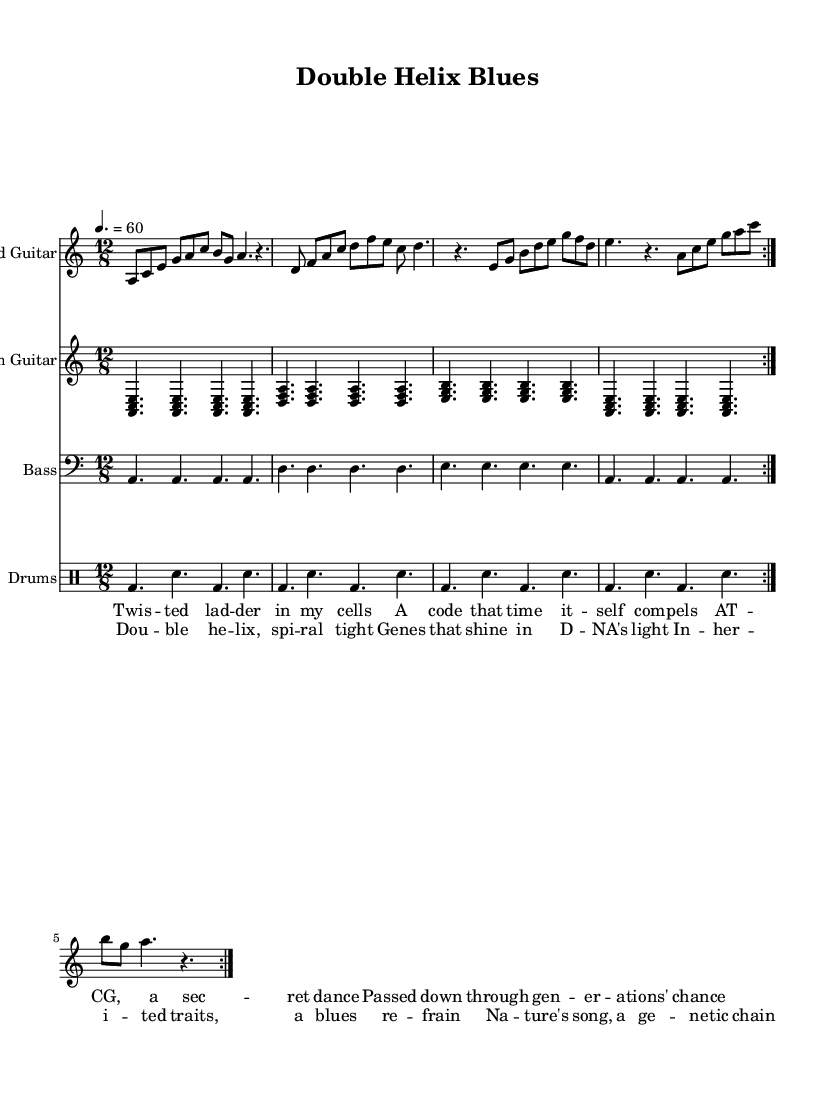What is the key signature of this music? The key signature is A minor, which has no sharps or flats. A minor is often indicated by the absence of any sharp or flat symbols at the beginning of the staff.
Answer: A minor What is the time signature of this music? The time signature is 12/8, which means there are four beats in a measure and the eighth note gets the beat. This is indicated at the beginning of the sheet music next to the clef.
Answer: 12/8 What is the tempo marking for this piece? The tempo marking is 60 beats per minute. This indicates how fast the piece should be played, and is found above the staff in the tempo indication.
Answer: 60 How many times is the main progression repeated in the electric guitar part? The main progression is repeated two times, which is indicated by the "volta" notation and the repeats in the score.
Answer: 2 What is the lyric theme of the chorus? The theme of the chorus reflects on genetic inheritance, discussing elements like the double helix and DNA's light. This theme can be inferred from the wording of the lyrics provided in the score.
Answer: Genetic inheritance What musical forms are present in this piece? The piece generally follows a verse-chorus structure, as indicated by the separate lyrics sections "verse" and "chorus", typical for blues music where storytelling is often divided into distinct sections.
Answer: Verse-chorus How do the guitar parts contribute to the blues style in this music? The guitar parts include a call-and-response structure, characteristic of the blues, where the lead guitar phrases are answered by rhythm guitar chords, creating a conversational effect. This can be seen in the alternation of melodic lines and harmonic support.
Answer: Call-and-response 